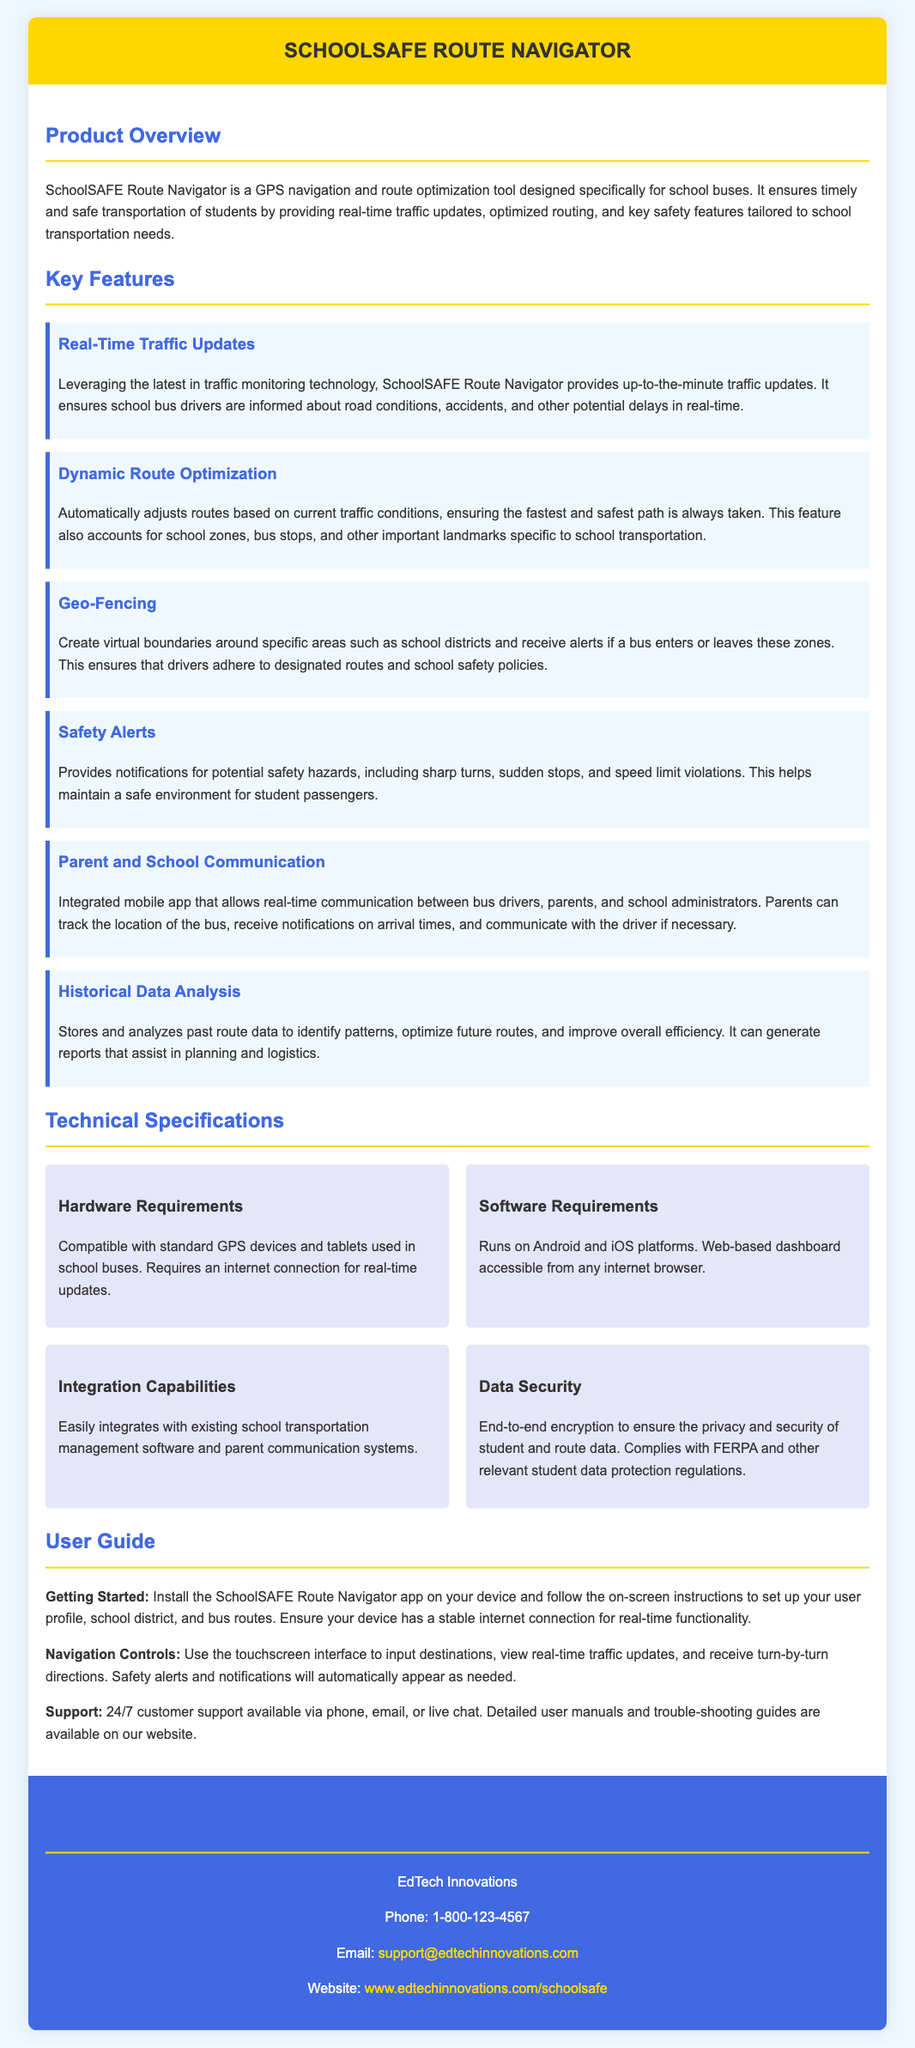what is the name of the product? The name of the product is prominently stated at the top of the document.
Answer: SchoolSAFE Route Navigator who is the manufacturer? The manufacturer is mentioned in the contact information section of the document.
Answer: EdTech Innovations what feature provides notifications for potential safety hazards? The feature related to safety notifications is highlighted within the key features section.
Answer: Safety Alerts what platforms does the software run on? The software requirements specify the compatible platforms listed in the document.
Answer: Android and iOS how many key features are listed in total? Counting the number of features mentioned in the key features section gives the total.
Answer: Six what type of communication does the integrated mobile app facilitate? The document describes the functionality of the mobile app within a specific feature.
Answer: Real-time communication what kind of data does the tool analyze for future route optimization? This information is found in the historical data analysis feature description.
Answer: Past route data how can bus drivers receive traffic updates? The method for receiving traffic updates is explained in the product overview section.
Answer: Real-time updates what is the customer support availability? The user guide indicates the support availability mentioned there.
Answer: 24/7 customer support 